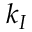Convert formula to latex. <formula><loc_0><loc_0><loc_500><loc_500>k _ { I }</formula> 